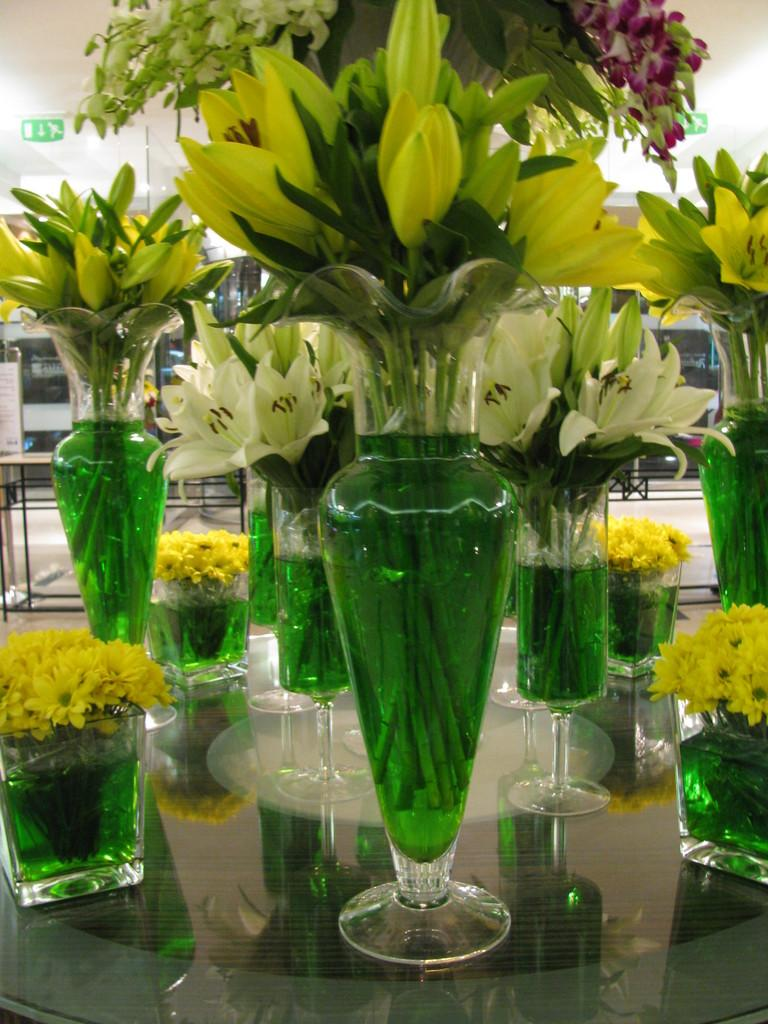What objects are on the table in the image? There are flower pots on a table in the image. What type of lighting is present in the image? There is a light hanging from the roof in the image. What type of doors can be seen in the image? There are glass doors in the image. What type of disease is being treated in the image? There is no indication of any disease or medical treatment in the image. What type of vest is being worn by the person in the image? There is no person present in the image, so it is impossible to determine if anyone is wearing a vest. 